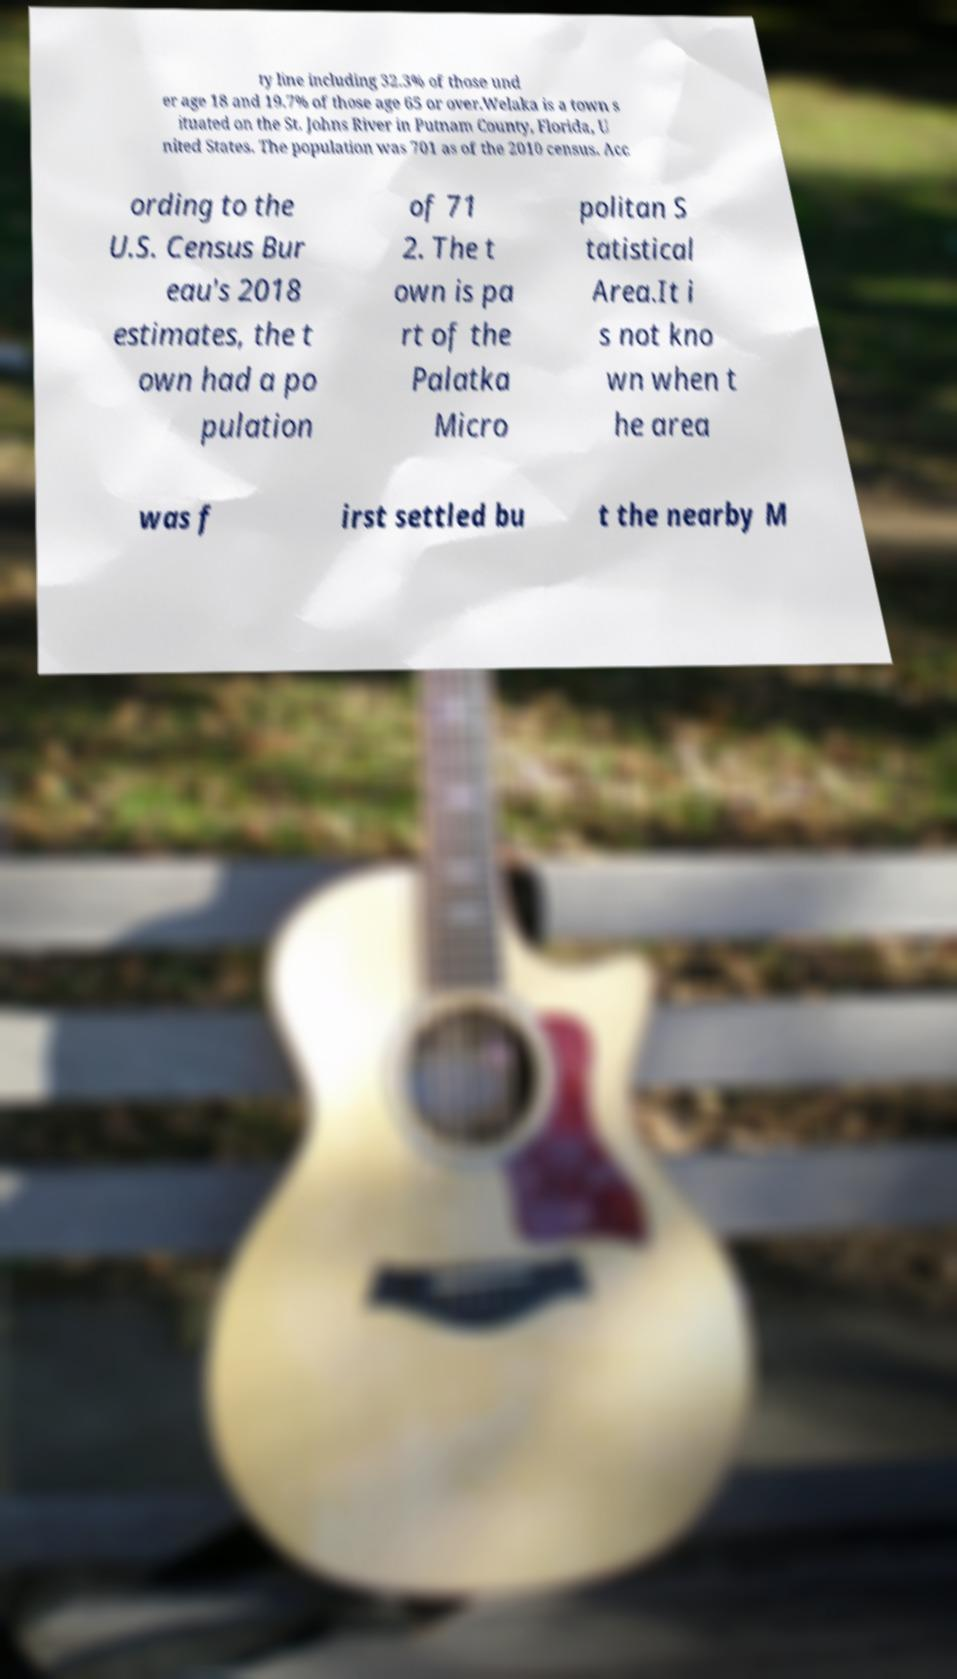What messages or text are displayed in this image? I need them in a readable, typed format. ty line including 32.3% of those und er age 18 and 19.7% of those age 65 or over.Welaka is a town s ituated on the St. Johns River in Putnam County, Florida, U nited States. The population was 701 as of the 2010 census. Acc ording to the U.S. Census Bur eau's 2018 estimates, the t own had a po pulation of 71 2. The t own is pa rt of the Palatka Micro politan S tatistical Area.It i s not kno wn when t he area was f irst settled bu t the nearby M 